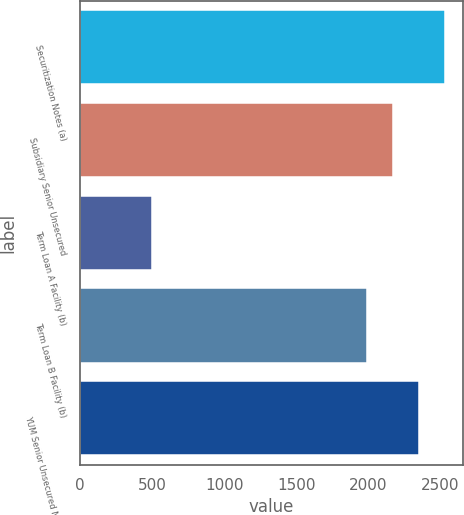Convert chart. <chart><loc_0><loc_0><loc_500><loc_500><bar_chart><fcel>Securitization Notes (a)<fcel>Subsidiary Senior Unsecured<fcel>Term Loan A Facility (b)<fcel>Term Loan B Facility (b)<fcel>YUM Senior Unsecured Notes (b)<nl><fcel>2528.2<fcel>2169.4<fcel>500<fcel>1990<fcel>2348.8<nl></chart> 